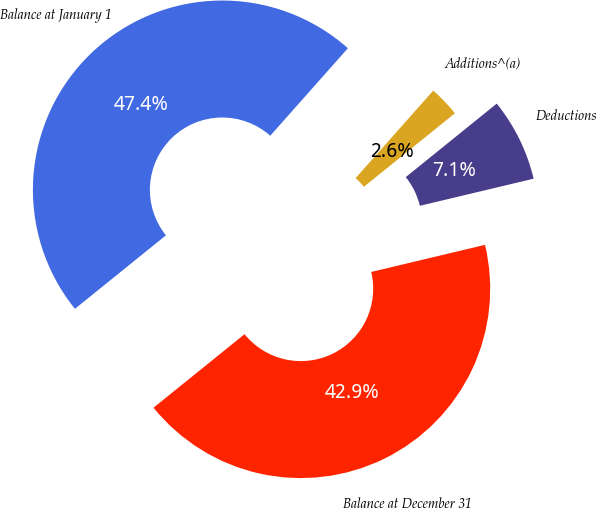<chart> <loc_0><loc_0><loc_500><loc_500><pie_chart><fcel>Balance at January 1<fcel>Additions^(a)<fcel>Deductions<fcel>Balance at December 31<nl><fcel>47.36%<fcel>2.64%<fcel>7.09%<fcel>42.91%<nl></chart> 